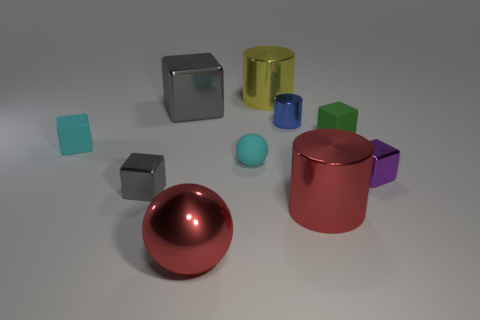What is the color of the tiny rubber block that is to the right of the big red metal cylinder?
Offer a terse response. Green. What is the shape of the matte object that is to the right of the large red thing that is to the right of the yellow cylinder?
Your answer should be very brief. Cube. Are the big yellow cylinder and the gray thing that is to the left of the big gray object made of the same material?
Your answer should be very brief. Yes. What shape is the small shiny thing that is the same color as the big cube?
Offer a very short reply. Cube. How many red metallic spheres have the same size as the blue cylinder?
Your answer should be compact. 0. Is the number of blue shiny objects right of the green cube less than the number of cyan matte cylinders?
Your answer should be very brief. No. There is a small blue cylinder; what number of large red metallic things are right of it?
Your answer should be very brief. 1. What is the size of the red thing to the left of the big red metal object behind the shiny object in front of the big red shiny cylinder?
Provide a short and direct response. Large. There is a purple metal thing; does it have the same shape as the large thing behind the large gray cube?
Offer a very short reply. No. What size is the purple object that is the same material as the big red cylinder?
Your response must be concise. Small. 